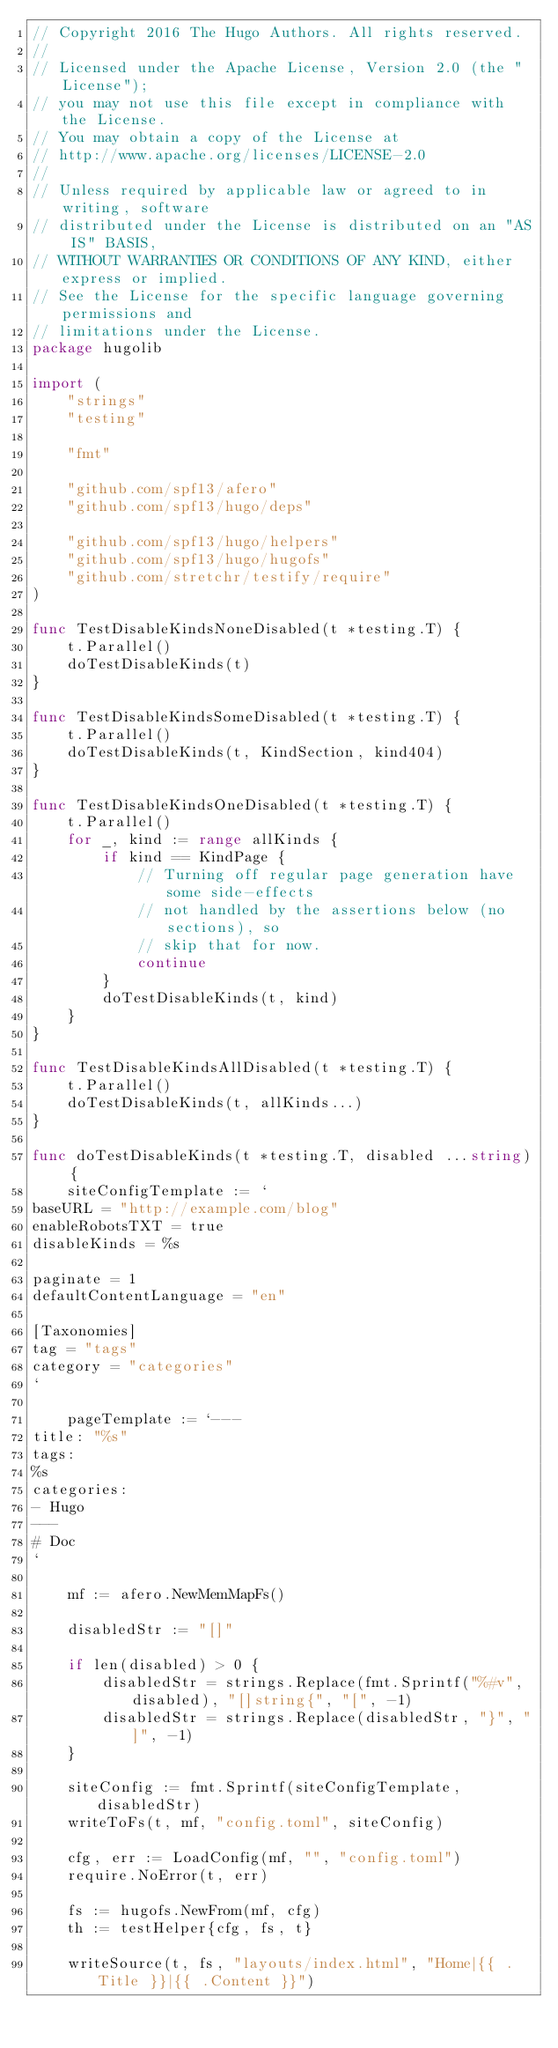Convert code to text. <code><loc_0><loc_0><loc_500><loc_500><_Go_>// Copyright 2016 The Hugo Authors. All rights reserved.
//
// Licensed under the Apache License, Version 2.0 (the "License");
// you may not use this file except in compliance with the License.
// You may obtain a copy of the License at
// http://www.apache.org/licenses/LICENSE-2.0
//
// Unless required by applicable law or agreed to in writing, software
// distributed under the License is distributed on an "AS IS" BASIS,
// WITHOUT WARRANTIES OR CONDITIONS OF ANY KIND, either express or implied.
// See the License for the specific language governing permissions and
// limitations under the License.
package hugolib

import (
	"strings"
	"testing"

	"fmt"

	"github.com/spf13/afero"
	"github.com/spf13/hugo/deps"

	"github.com/spf13/hugo/helpers"
	"github.com/spf13/hugo/hugofs"
	"github.com/stretchr/testify/require"
)

func TestDisableKindsNoneDisabled(t *testing.T) {
	t.Parallel()
	doTestDisableKinds(t)
}

func TestDisableKindsSomeDisabled(t *testing.T) {
	t.Parallel()
	doTestDisableKinds(t, KindSection, kind404)
}

func TestDisableKindsOneDisabled(t *testing.T) {
	t.Parallel()
	for _, kind := range allKinds {
		if kind == KindPage {
			// Turning off regular page generation have some side-effects
			// not handled by the assertions below (no sections), so
			// skip that for now.
			continue
		}
		doTestDisableKinds(t, kind)
	}
}

func TestDisableKindsAllDisabled(t *testing.T) {
	t.Parallel()
	doTestDisableKinds(t, allKinds...)
}

func doTestDisableKinds(t *testing.T, disabled ...string) {
	siteConfigTemplate := `
baseURL = "http://example.com/blog"
enableRobotsTXT = true
disableKinds = %s

paginate = 1
defaultContentLanguage = "en"

[Taxonomies]
tag = "tags"
category = "categories"
`

	pageTemplate := `---
title: "%s"
tags:
%s
categories:
- Hugo
---
# Doc
`

	mf := afero.NewMemMapFs()

	disabledStr := "[]"

	if len(disabled) > 0 {
		disabledStr = strings.Replace(fmt.Sprintf("%#v", disabled), "[]string{", "[", -1)
		disabledStr = strings.Replace(disabledStr, "}", "]", -1)
	}

	siteConfig := fmt.Sprintf(siteConfigTemplate, disabledStr)
	writeToFs(t, mf, "config.toml", siteConfig)

	cfg, err := LoadConfig(mf, "", "config.toml")
	require.NoError(t, err)

	fs := hugofs.NewFrom(mf, cfg)
	th := testHelper{cfg, fs, t}

	writeSource(t, fs, "layouts/index.html", "Home|{{ .Title }}|{{ .Content }}")</code> 